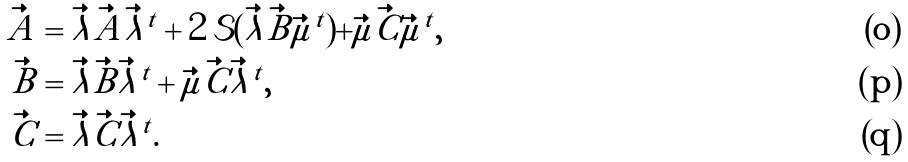<formula> <loc_0><loc_0><loc_500><loc_500>\vec { A } & = \vec { \lambda } \vec { \tilde { A } } \vec { \lambda } ^ { t } + 2 \, \mathcal { S } ( \vec { \lambda } \vec { \tilde { B } } \vec { \mu } ^ { t } ) + \vec { \mu } \vec { \tilde { C } } \vec { \mu } ^ { t } , \\ \vec { B } & = \vec { \lambda } \vec { \tilde { B } } \vec { \lambda } ^ { t } + \vec { \mu } \vec { \tilde { C } } \vec { \lambda } ^ { t } , \\ \vec { C } & = \vec { \lambda } \vec { \tilde { C } } \vec { \lambda } ^ { t } .</formula> 